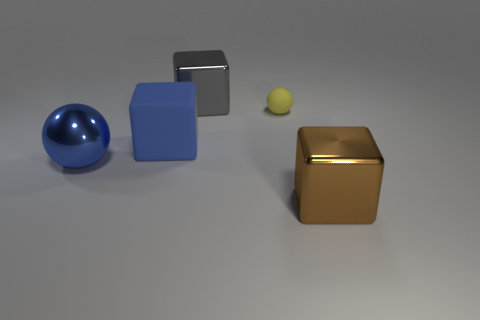Is there any other thing that has the same size as the matte sphere?
Your response must be concise. No. Is the shape of the big shiny object to the left of the blue rubber block the same as the rubber thing on the right side of the gray thing?
Your answer should be compact. Yes. What is the color of the metallic block that is to the left of the large brown object?
Offer a terse response. Gray. Are there any metal objects that have the same shape as the big blue rubber object?
Offer a terse response. Yes. What is the gray thing made of?
Provide a short and direct response. Metal. There is a shiny object that is both in front of the small yellow thing and to the right of the big blue ball; what is its size?
Make the answer very short. Large. There is a large block that is the same color as the large metallic ball; what is its material?
Give a very brief answer. Rubber. What number of objects are there?
Keep it short and to the point. 5. Is the number of big matte cubes less than the number of big brown cylinders?
Keep it short and to the point. No. There is a blue thing that is the same size as the blue shiny ball; what material is it?
Make the answer very short. Rubber. 